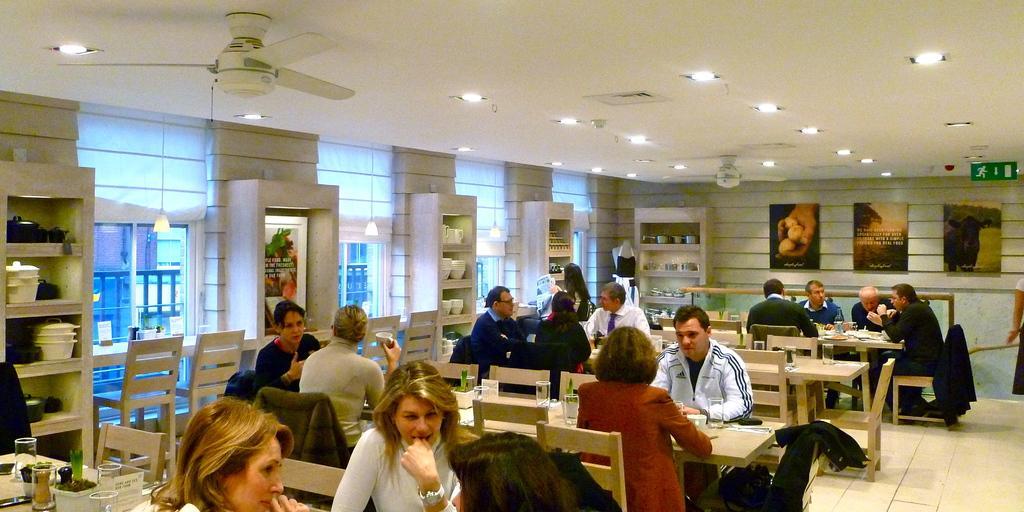Describe this image in one or two sentences. In this picture we can see some people where they are sitting on chair and in front of them there are table and on table we can see glasses, jars, flower pots with plants in it and on some chairs jackets are kept and in the background we can see dishes in rack, windows, frames, wall, sign board, light, fan. 